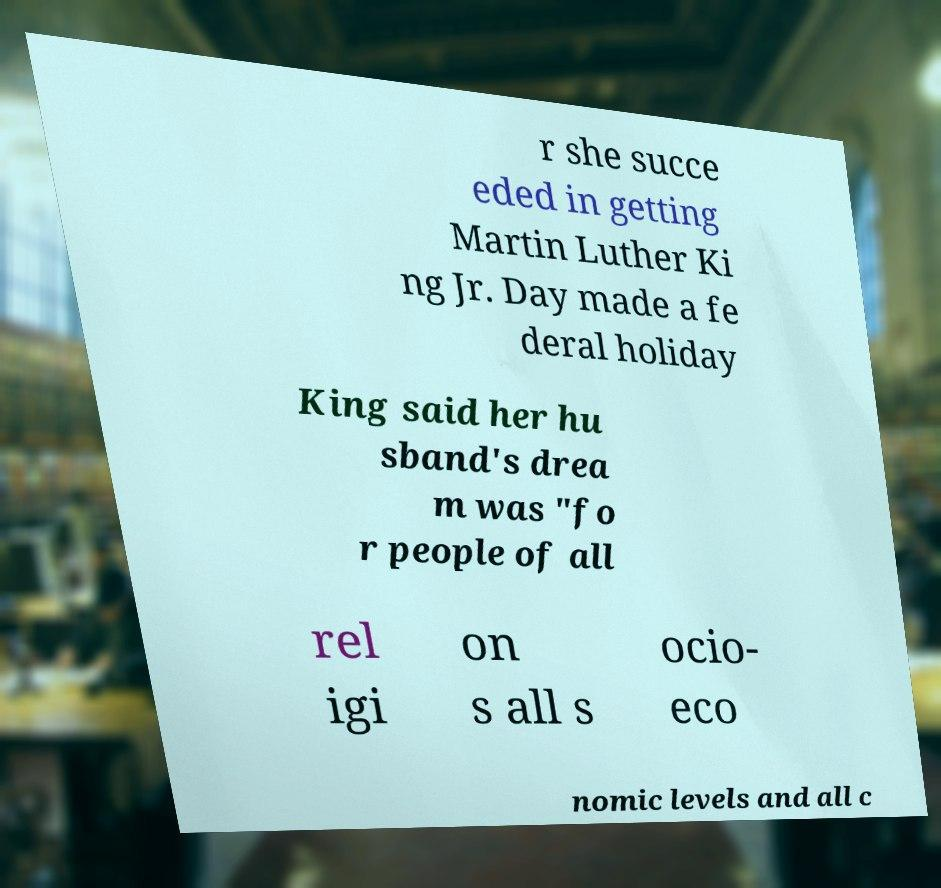Could you extract and type out the text from this image? r she succe eded in getting Martin Luther Ki ng Jr. Day made a fe deral holiday King said her hu sband's drea m was "fo r people of all rel igi on s all s ocio- eco nomic levels and all c 